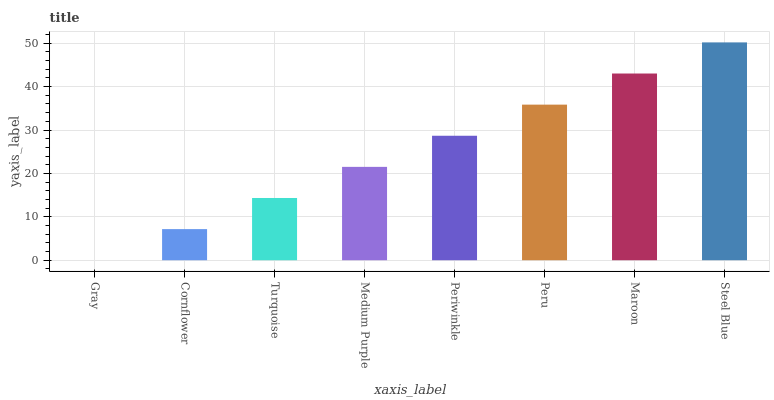Is Gray the minimum?
Answer yes or no. Yes. Is Steel Blue the maximum?
Answer yes or no. Yes. Is Cornflower the minimum?
Answer yes or no. No. Is Cornflower the maximum?
Answer yes or no. No. Is Cornflower greater than Gray?
Answer yes or no. Yes. Is Gray less than Cornflower?
Answer yes or no. Yes. Is Gray greater than Cornflower?
Answer yes or no. No. Is Cornflower less than Gray?
Answer yes or no. No. Is Periwinkle the high median?
Answer yes or no. Yes. Is Medium Purple the low median?
Answer yes or no. Yes. Is Maroon the high median?
Answer yes or no. No. Is Steel Blue the low median?
Answer yes or no. No. 